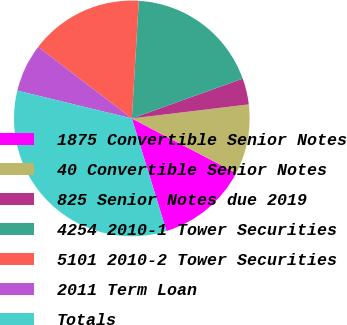<chart> <loc_0><loc_0><loc_500><loc_500><pie_chart><fcel>1875 Convertible Senior Notes<fcel>40 Convertible Senior Notes<fcel>825 Senior Notes due 2019<fcel>4254 2010-1 Tower Securities<fcel>5101 2010-2 Tower Securities<fcel>2011 Term Loan<fcel>Totals<nl><fcel>12.57%<fcel>9.58%<fcel>3.58%<fcel>18.57%<fcel>15.57%<fcel>6.58%<fcel>33.55%<nl></chart> 